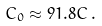Convert formula to latex. <formula><loc_0><loc_0><loc_500><loc_500>C _ { 0 } \approx 9 1 . 8 C \, .</formula> 